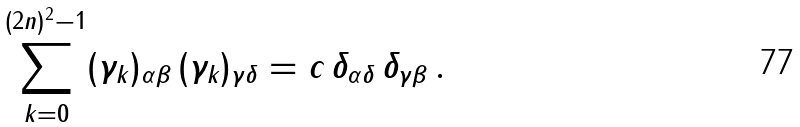<formula> <loc_0><loc_0><loc_500><loc_500>\sum ^ { ( 2 n ) ^ { 2 } - 1 } _ { k = 0 } ( \gamma _ { k } ) _ { \alpha \beta } \, ( \gamma _ { k } ) _ { \gamma \delta } = c \, \delta _ { \alpha \delta } \, \delta _ { \gamma \beta } \, .</formula> 